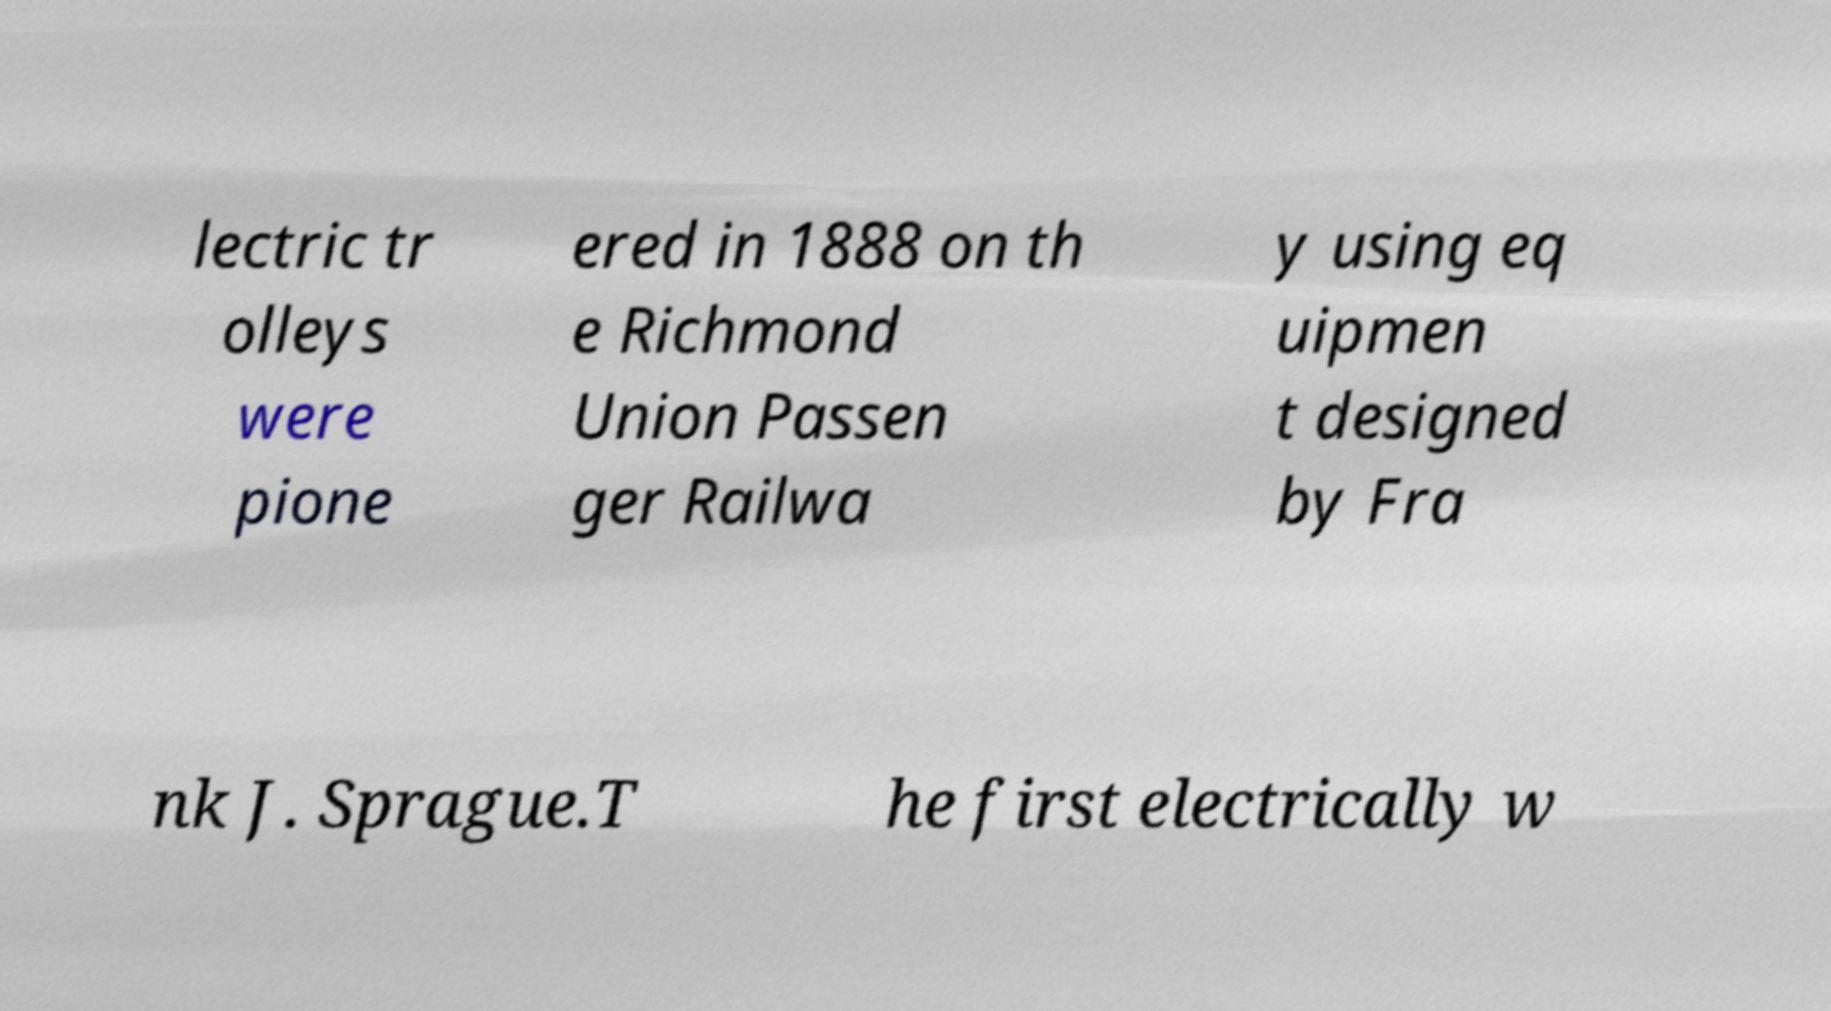Could you extract and type out the text from this image? lectric tr olleys were pione ered in 1888 on th e Richmond Union Passen ger Railwa y using eq uipmen t designed by Fra nk J. Sprague.T he first electrically w 